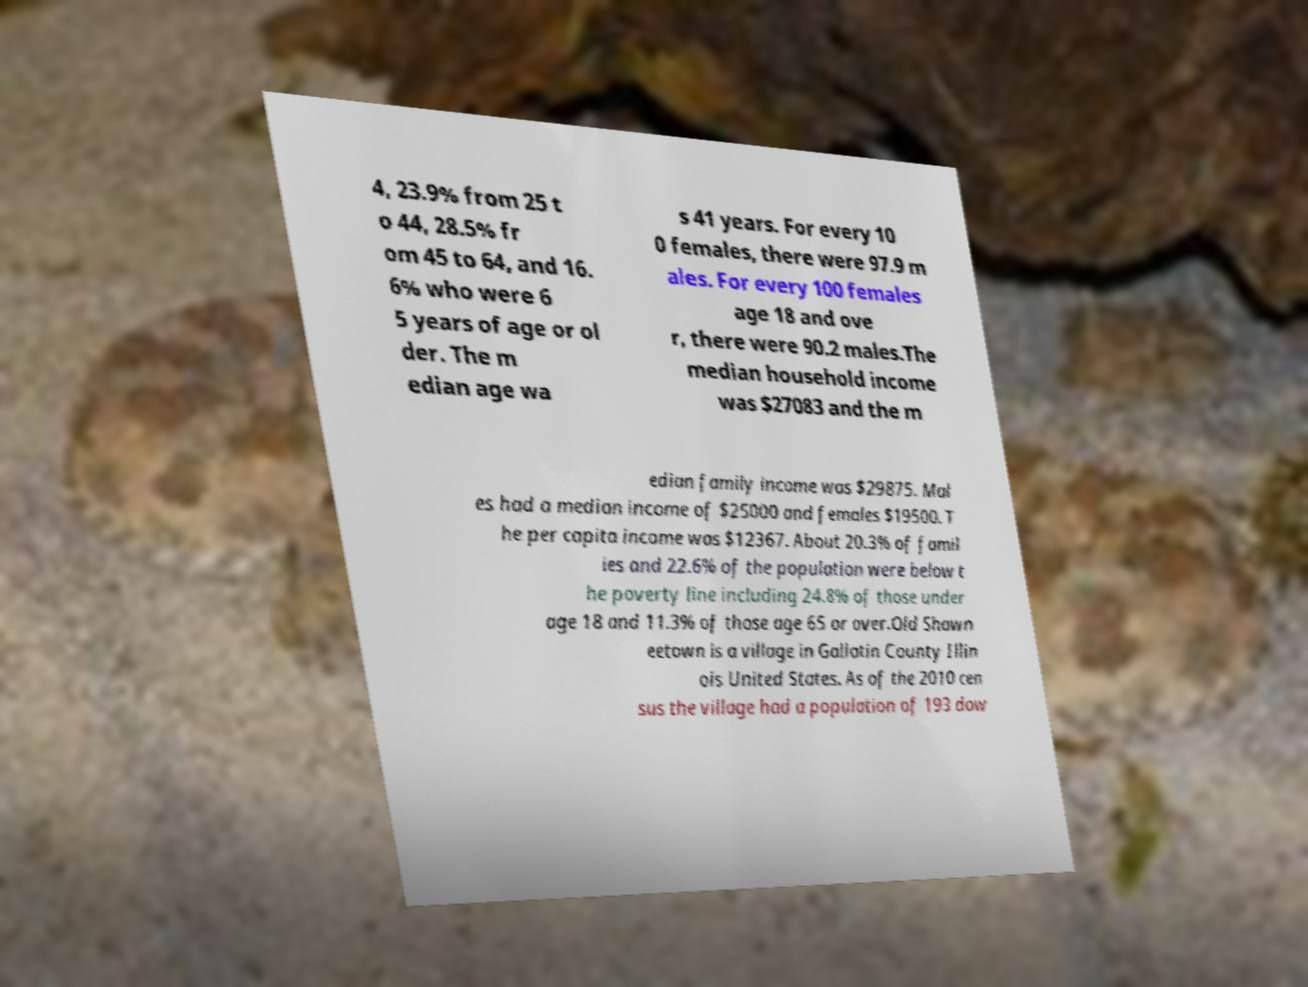Could you extract and type out the text from this image? 4, 23.9% from 25 t o 44, 28.5% fr om 45 to 64, and 16. 6% who were 6 5 years of age or ol der. The m edian age wa s 41 years. For every 10 0 females, there were 97.9 m ales. For every 100 females age 18 and ove r, there were 90.2 males.The median household income was $27083 and the m edian family income was $29875. Mal es had a median income of $25000 and females $19500. T he per capita income was $12367. About 20.3% of famil ies and 22.6% of the population were below t he poverty line including 24.8% of those under age 18 and 11.3% of those age 65 or over.Old Shawn eetown is a village in Gallatin County Illin ois United States. As of the 2010 cen sus the village had a population of 193 dow 